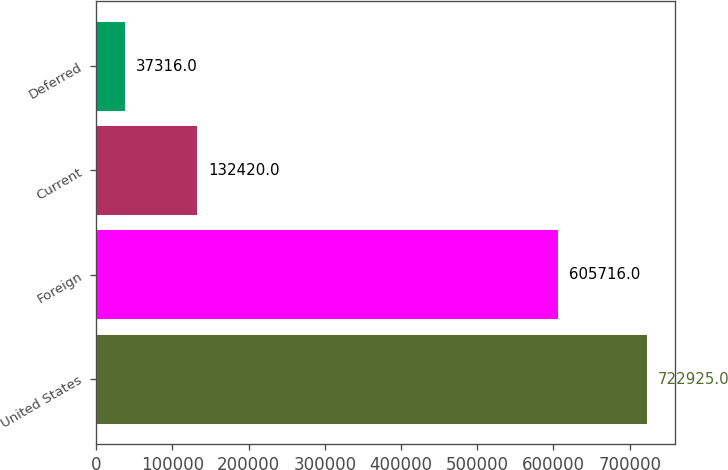Convert chart to OTSL. <chart><loc_0><loc_0><loc_500><loc_500><bar_chart><fcel>United States<fcel>Foreign<fcel>Current<fcel>Deferred<nl><fcel>722925<fcel>605716<fcel>132420<fcel>37316<nl></chart> 